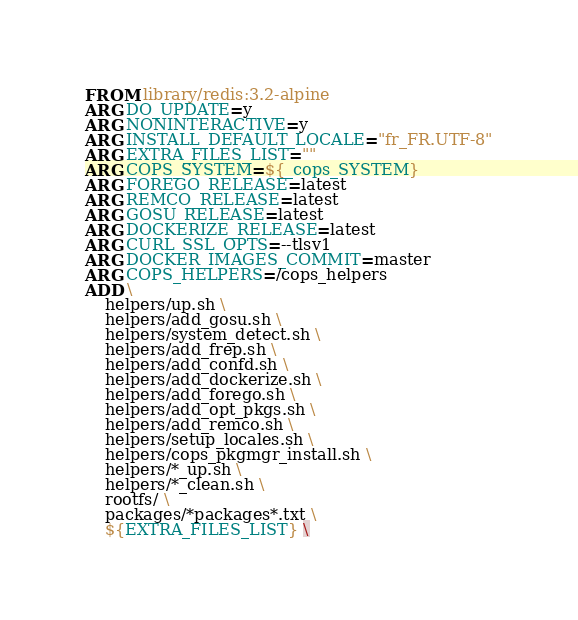<code> <loc_0><loc_0><loc_500><loc_500><_Dockerfile_>FROM library/redis:3.2-alpine
ARG DO_UPDATE=y
ARG NONINTERACTIVE=y
ARG INSTALL_DEFAULT_LOCALE="fr_FR.UTF-8"
ARG EXTRA_FILES_LIST=""
ARG COPS_SYSTEM=${_cops_SYSTEM}
ARG FOREGO_RELEASE=latest
ARG REMCO_RELEASE=latest
ARG GOSU_RELEASE=latest
ARG DOCKERIZE_RELEASE=latest
ARG CURL_SSL_OPTS=--tlsv1
ARG DOCKER_IMAGES_COMMIT=master
ARG COPS_HELPERS=/cops_helpers
ADD \
    helpers/up.sh \
    helpers/add_gosu.sh \
    helpers/system_detect.sh \
    helpers/add_frep.sh \
    helpers/add_confd.sh \
    helpers/add_dockerize.sh \
    helpers/add_forego.sh \
    helpers/add_opt_pkgs.sh \
    helpers/add_remco.sh \
    helpers/setup_locales.sh \
    helpers/cops_pkgmgr_install.sh \
    helpers/*_up.sh \
    helpers/*_clean.sh \
    rootfs/ \
    packages/*packages*.txt \
    ${EXTRA_FILES_LIST} \</code> 